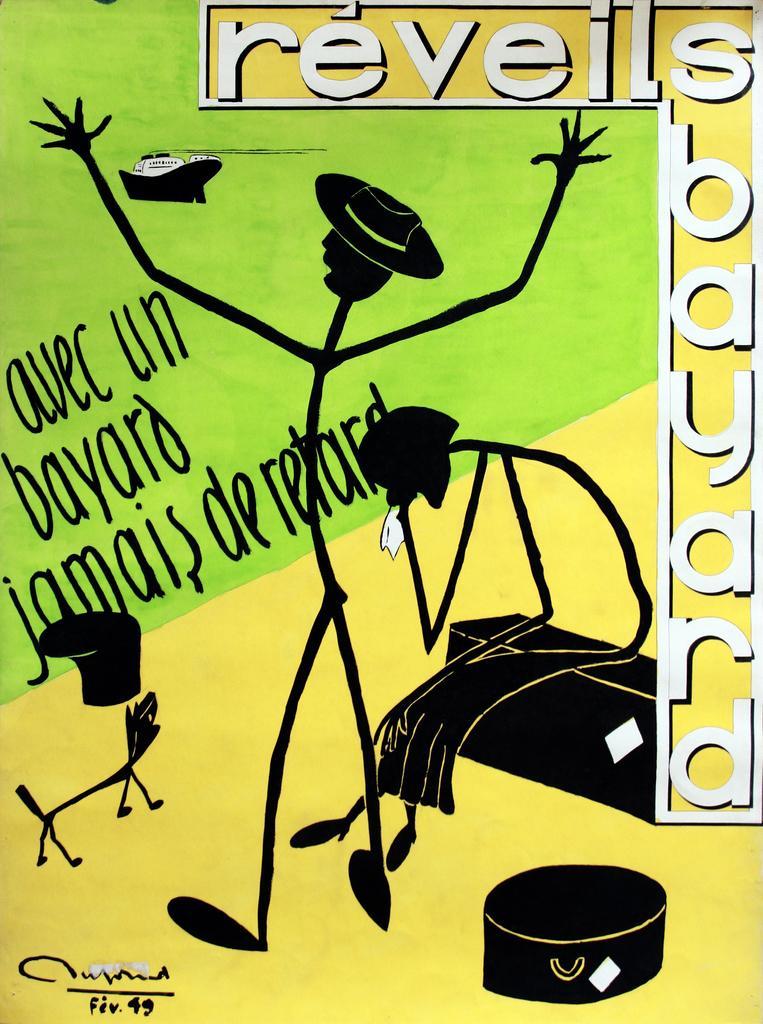In one or two sentences, can you explain what this image depicts? This image consists of a poster. On this poster, I can see some text and cartoon images. 